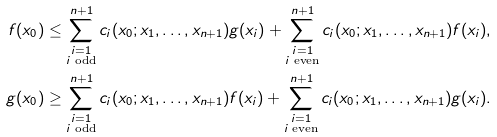<formula> <loc_0><loc_0><loc_500><loc_500>f ( x _ { 0 } ) & \leq \sum _ { \substack { i = 1 \\ i \text {\ {odd}} } } ^ { n + 1 } c _ { i } ( x _ { 0 } ; x _ { 1 } , \dots , x _ { n + 1 } ) g ( x _ { i } ) + \sum _ { \substack { i = 1 \\ i \text {\ {even}} } } ^ { n + 1 } c _ { i } ( x _ { 0 } ; x _ { 1 } , \dots , x _ { n + 1 } ) f ( x _ { i } ) , \\ g ( x _ { 0 } ) & \geq \sum _ { \substack { i = 1 \\ i \text {\ {odd}} } } ^ { n + 1 } c _ { i } ( x _ { 0 } ; x _ { 1 } , \dots , x _ { n + 1 } ) f ( x _ { i } ) + \sum _ { \substack { i = 1 \\ i \text {\ {even}} } } ^ { n + 1 } c _ { i } ( x _ { 0 } ; x _ { 1 } , \dots , x _ { n + 1 } ) g ( x _ { i } ) .</formula> 